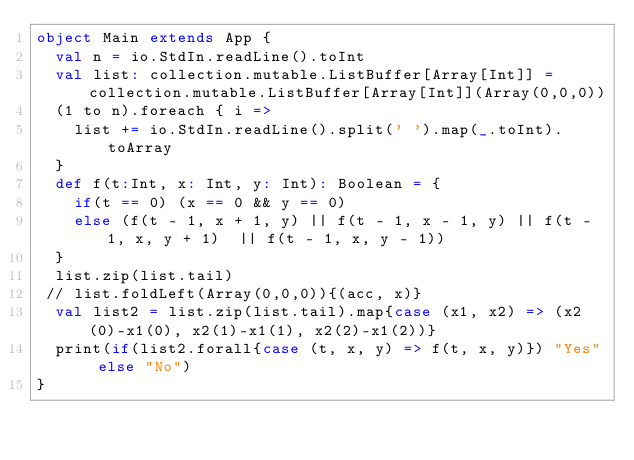Convert code to text. <code><loc_0><loc_0><loc_500><loc_500><_Scala_>object Main extends App {
  val n = io.StdIn.readLine().toInt
  val list: collection.mutable.ListBuffer[Array[Int]] = collection.mutable.ListBuffer[Array[Int]](Array(0,0,0))
  (1 to n).foreach { i =>
    list += io.StdIn.readLine().split(' ').map(_.toInt).toArray
  }  
  def f(t:Int, x: Int, y: Int): Boolean = {
    if(t == 0) (x == 0 && y == 0)
    else (f(t - 1, x + 1, y) || f(t - 1, x - 1, y) || f(t - 1, x, y + 1)  || f(t - 1, x, y - 1)) 
  }
  list.zip(list.tail)
 // list.foldLeft(Array(0,0,0)){(acc, x)}
  val list2 = list.zip(list.tail).map{case (x1, x2) => (x2(0)-x1(0), x2(1)-x1(1), x2(2)-x1(2))}
  print(if(list2.forall{case (t, x, y) => f(t, x, y)}) "Yes" else "No")
}</code> 